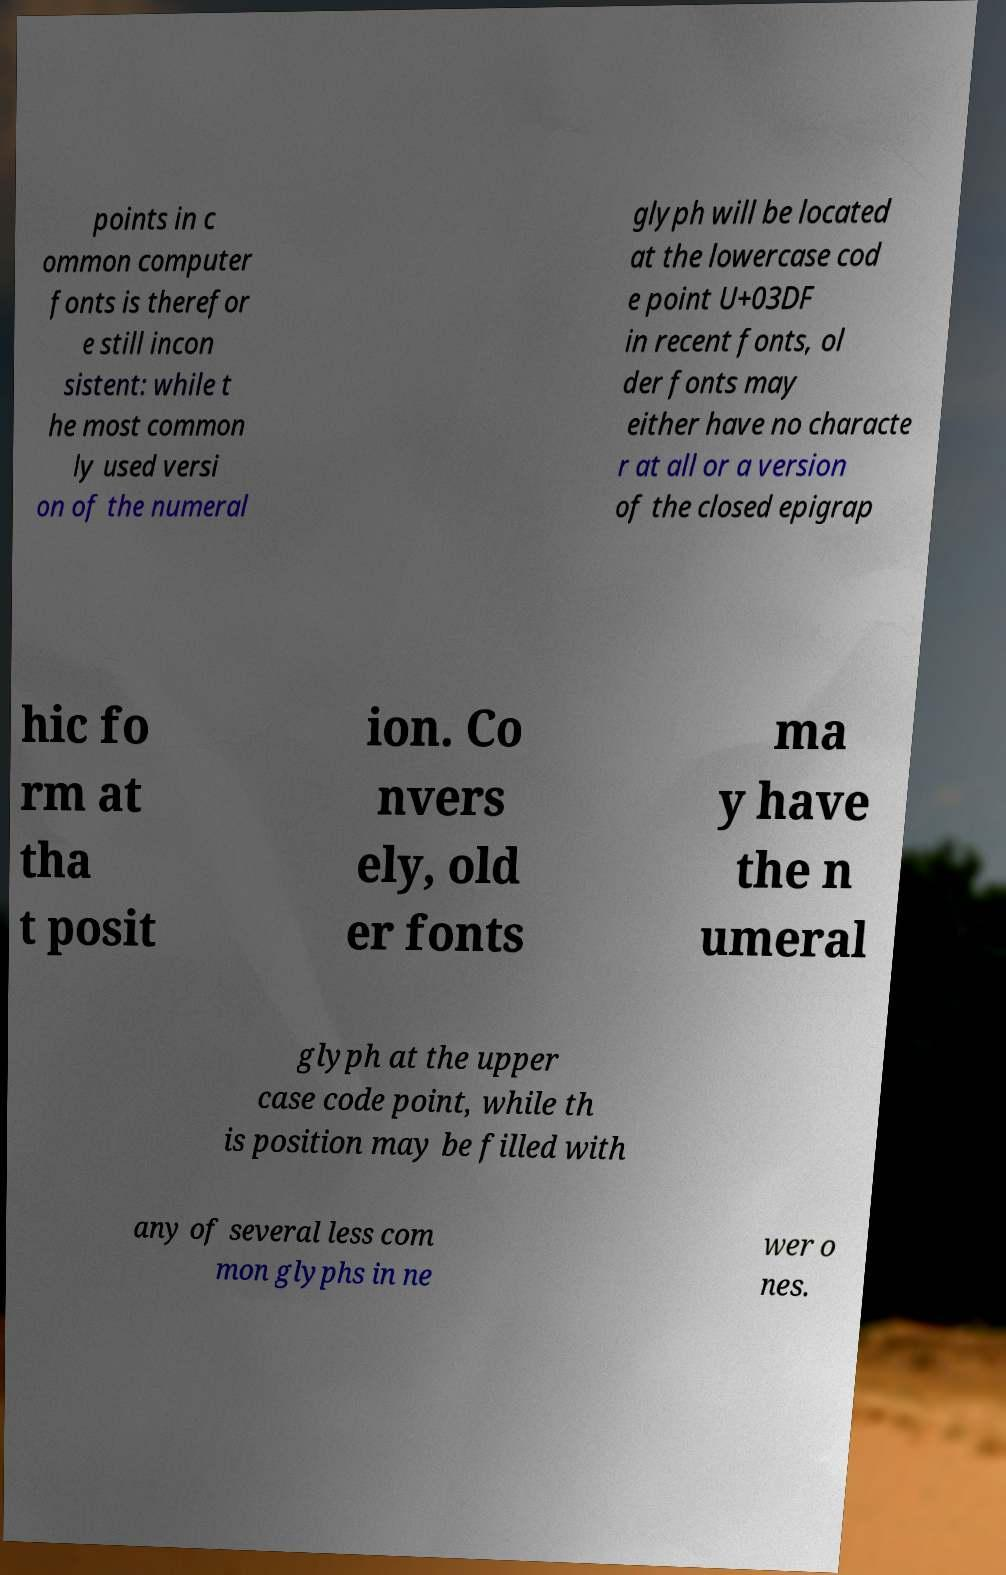Could you assist in decoding the text presented in this image and type it out clearly? points in c ommon computer fonts is therefor e still incon sistent: while t he most common ly used versi on of the numeral glyph will be located at the lowercase cod e point U+03DF in recent fonts, ol der fonts may either have no characte r at all or a version of the closed epigrap hic fo rm at tha t posit ion. Co nvers ely, old er fonts ma y have the n umeral glyph at the upper case code point, while th is position may be filled with any of several less com mon glyphs in ne wer o nes. 